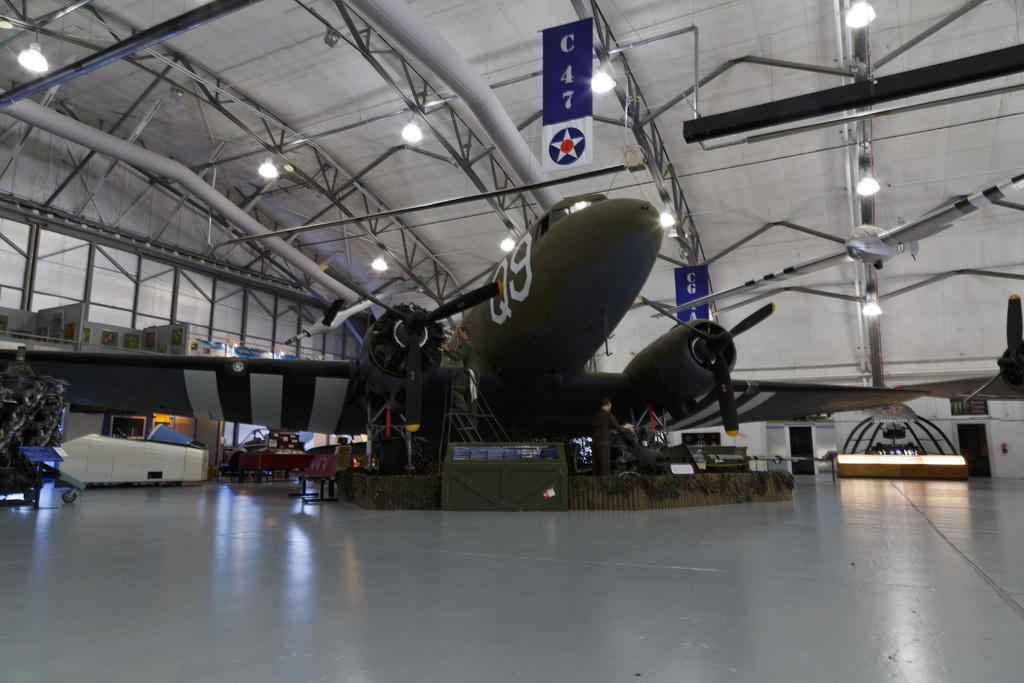<image>
Relay a brief, clear account of the picture shown. Q9 green airplane and a C47 banner above it with a star logo. 